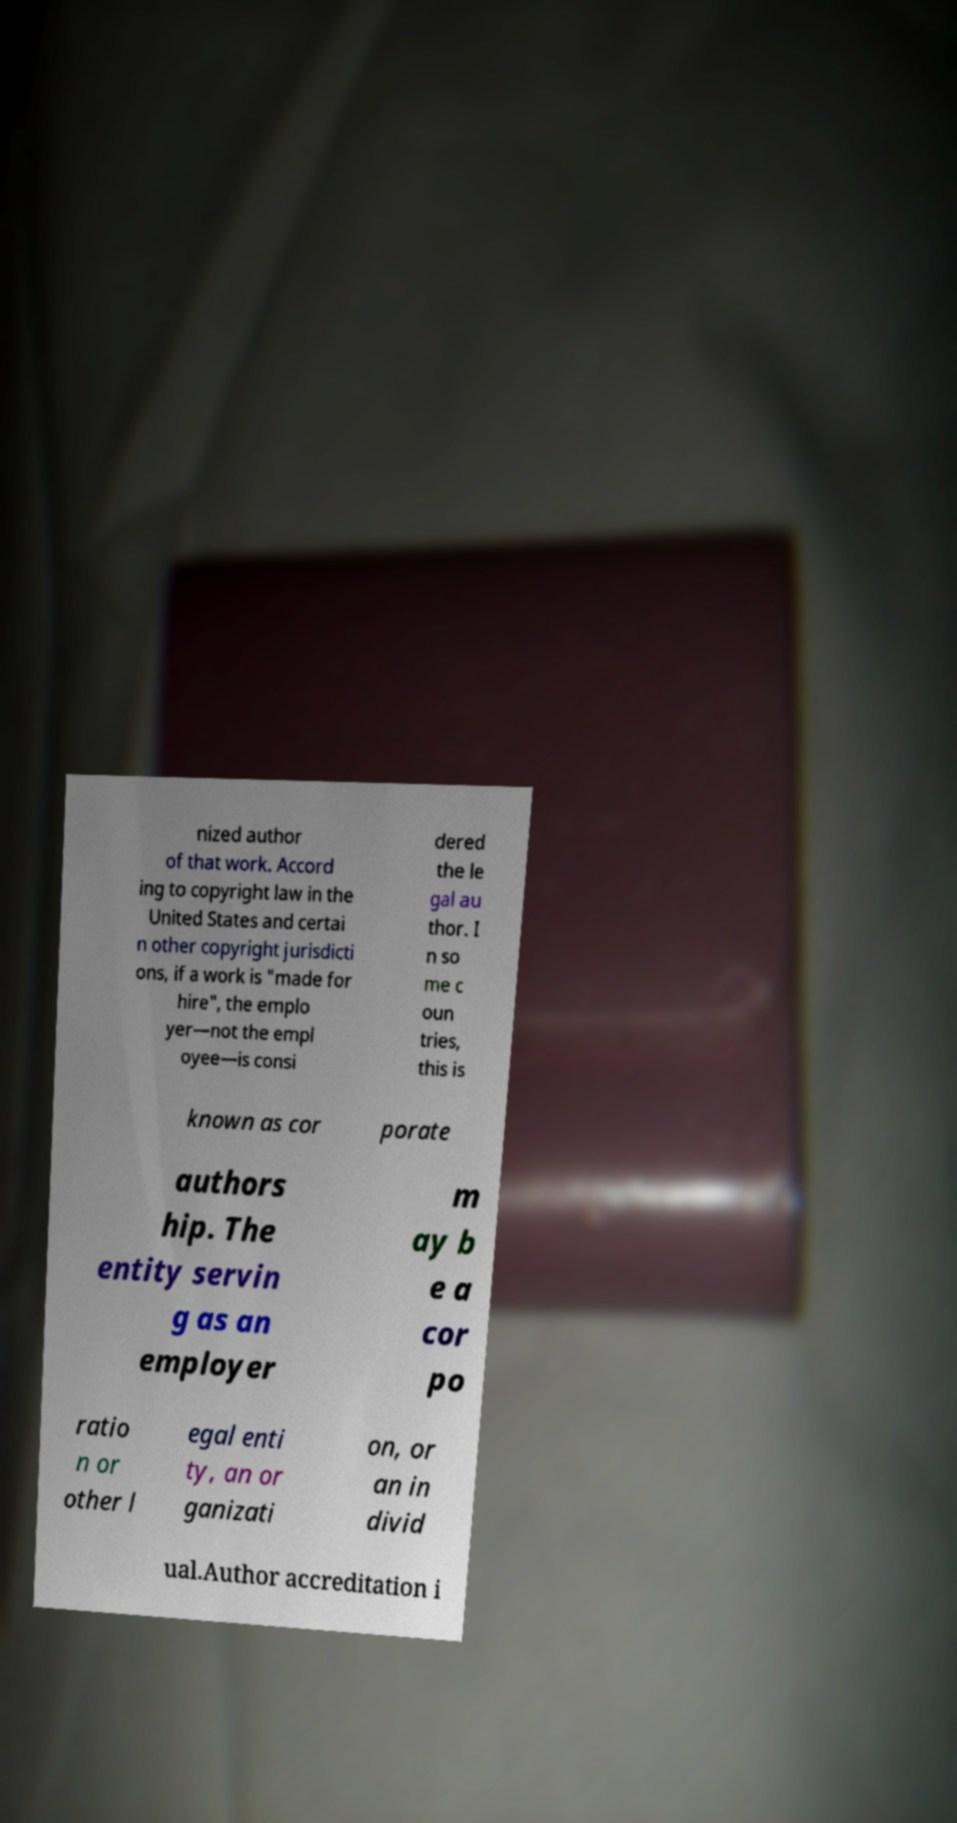Can you read and provide the text displayed in the image?This photo seems to have some interesting text. Can you extract and type it out for me? nized author of that work. Accord ing to copyright law in the United States and certai n other copyright jurisdicti ons, if a work is "made for hire", the emplo yer—not the empl oyee—is consi dered the le gal au thor. I n so me c oun tries, this is known as cor porate authors hip. The entity servin g as an employer m ay b e a cor po ratio n or other l egal enti ty, an or ganizati on, or an in divid ual.Author accreditation i 